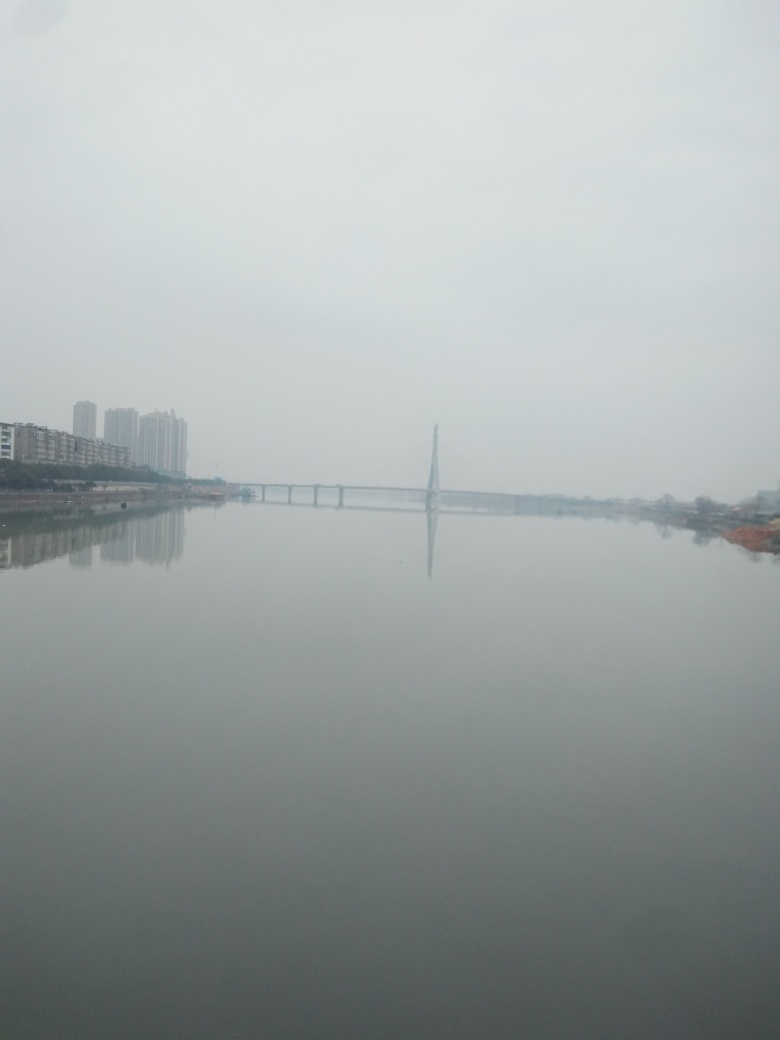What are the possible reasons for the lack of clarity in this image? The lack of clarity could be attributed to several factors including but not limited to weather conditions like fog, camera lens fogging, a dirty camera lens, or low camera resolution. Additionally, the camera's focus might not have been set correctly, or the photograph may have been taken with a rapid movement leading to a slight blur. 